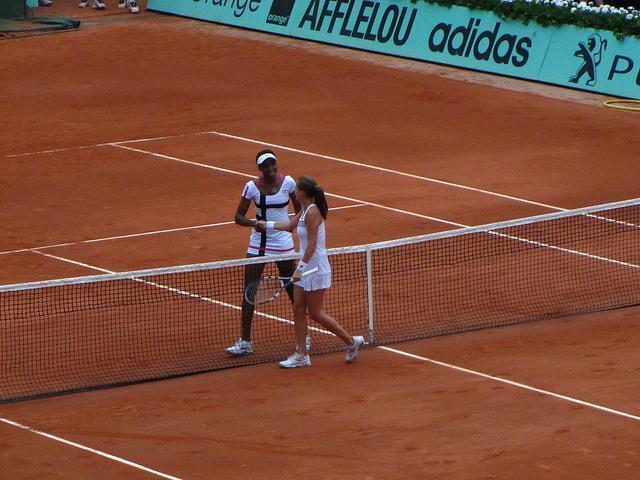How many people can be seen?
Give a very brief answer. 2. 